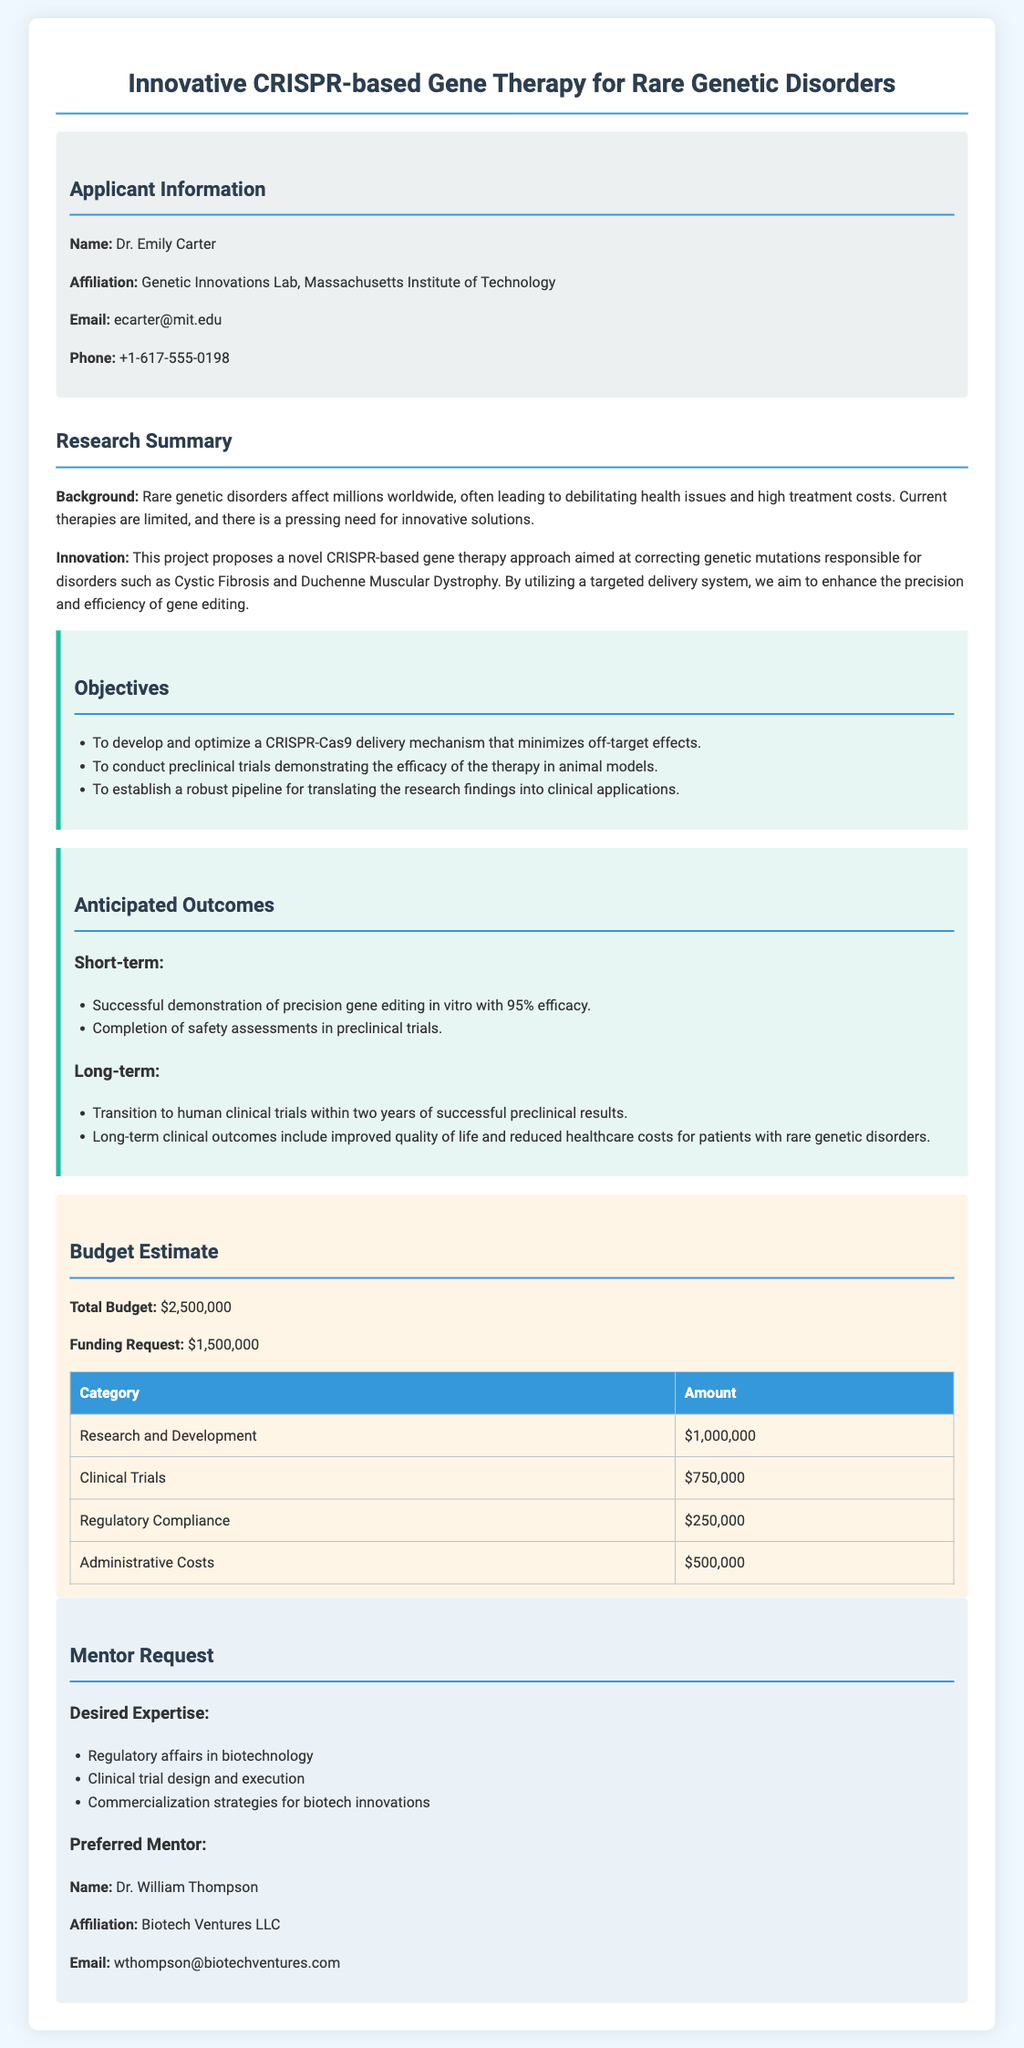What is the name of the applicant? The applicant's name is provided in the applicant information section of the document.
Answer: Dr. Emily Carter What is the total budget for the project? The total budget amount is specified in the budget estimate section of the document.
Answer: $2,500,000 What is the primary focus of the research? The focus of the research is outlined in the research summary section, which provides an overview of the innovation.
Answer: CRISPR-based gene therapy for rare genetic disorders How many objectives are outlined in the document? The number of objectives can be determined by counting the bulleted list provided in the objectives section.
Answer: Three What is the anticipated short-term outcome regarding efficacy? The anticipated short-term outcome is mentioned in the anticipated outcomes section.
Answer: 95% efficacy What is the preferred mentor's email address? The email address of the preferred mentor is provided in the mentor request section of the document.
Answer: wthompson@biotechventures.com How much funding is being requested? The requested funding amount is mentioned in the budget estimate section of the document.
Answer: $1,500,000 Which genetic disorders are targeted by the proposed therapy? The specific disorders targeted by the proposed therapy are detailed in the research summary section.
Answer: Cystic Fibrosis and Duchenne Muscular Dystrophy What is the affiliation of the applicant? The applicant's affiliation is stated in the applicant information section of the document.
Answer: Genetic Innovations Lab, Massachusetts Institute of Technology 